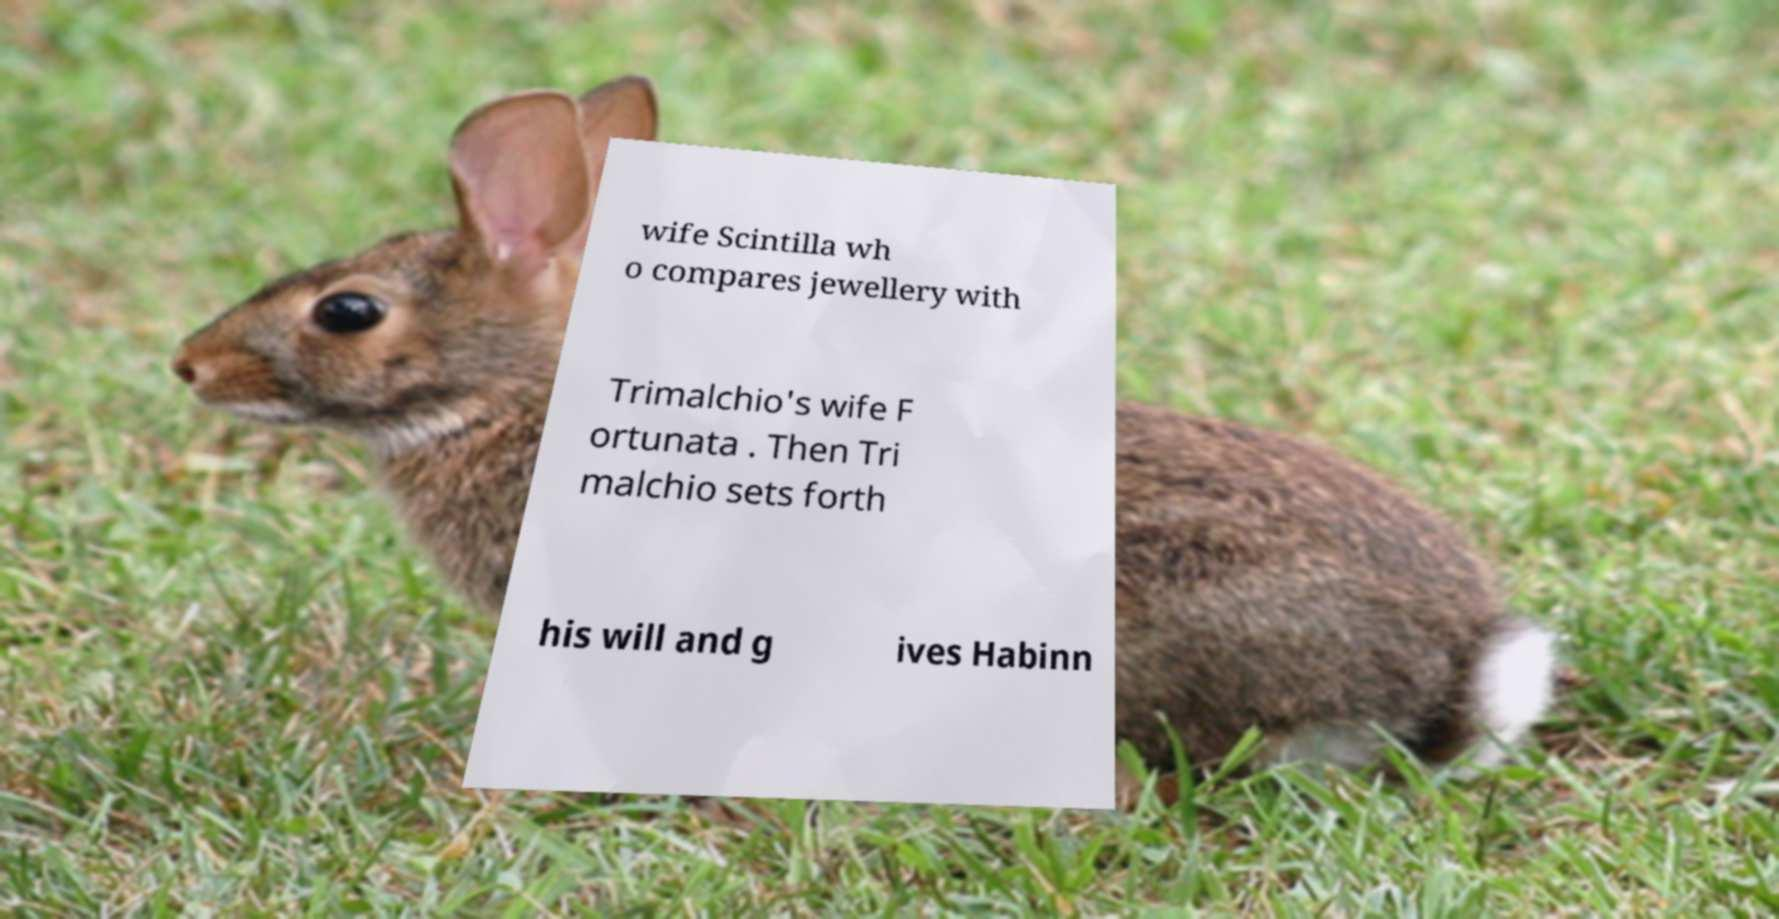Please identify and transcribe the text found in this image. wife Scintilla wh o compares jewellery with Trimalchio's wife F ortunata . Then Tri malchio sets forth his will and g ives Habinn 